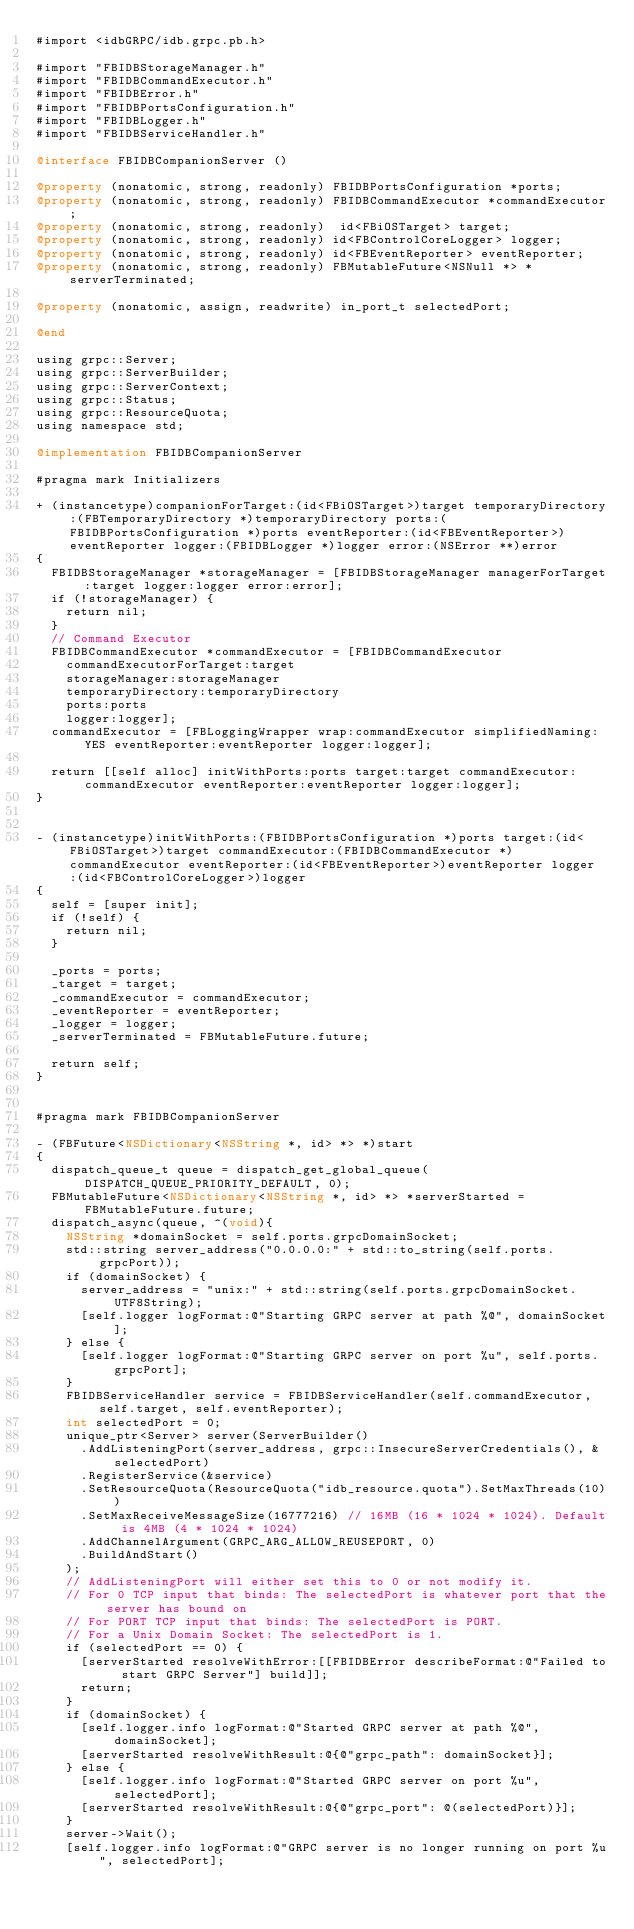<code> <loc_0><loc_0><loc_500><loc_500><_ObjectiveC_>#import <idbGRPC/idb.grpc.pb.h>

#import "FBIDBStorageManager.h"
#import "FBIDBCommandExecutor.h"
#import "FBIDBError.h"
#import "FBIDBPortsConfiguration.h"
#import "FBIDBLogger.h"
#import "FBIDBServiceHandler.h"

@interface FBIDBCompanionServer ()

@property (nonatomic, strong, readonly) FBIDBPortsConfiguration *ports;
@property (nonatomic, strong, readonly) FBIDBCommandExecutor *commandExecutor;
@property (nonatomic, strong, readonly)  id<FBiOSTarget> target;
@property (nonatomic, strong, readonly) id<FBControlCoreLogger> logger;
@property (nonatomic, strong, readonly) id<FBEventReporter> eventReporter;
@property (nonatomic, strong, readonly) FBMutableFuture<NSNull *> *serverTerminated;

@property (nonatomic, assign, readwrite) in_port_t selectedPort;

@end

using grpc::Server;
using grpc::ServerBuilder;
using grpc::ServerContext;
using grpc::Status;
using grpc::ResourceQuota;
using namespace std;

@implementation FBIDBCompanionServer

#pragma mark Initializers

+ (instancetype)companionForTarget:(id<FBiOSTarget>)target temporaryDirectory:(FBTemporaryDirectory *)temporaryDirectory ports:(FBIDBPortsConfiguration *)ports eventReporter:(id<FBEventReporter>)eventReporter logger:(FBIDBLogger *)logger error:(NSError **)error
{
  FBIDBStorageManager *storageManager = [FBIDBStorageManager managerForTarget:target logger:logger error:error];
  if (!storageManager) {
    return nil;
  }
  // Command Executor
  FBIDBCommandExecutor *commandExecutor = [FBIDBCommandExecutor
    commandExecutorForTarget:target
    storageManager:storageManager
    temporaryDirectory:temporaryDirectory
    ports:ports
    logger:logger];
  commandExecutor = [FBLoggingWrapper wrap:commandExecutor simplifiedNaming:YES eventReporter:eventReporter logger:logger];

  return [[self alloc] initWithPorts:ports target:target commandExecutor:commandExecutor eventReporter:eventReporter logger:logger];
}


- (instancetype)initWithPorts:(FBIDBPortsConfiguration *)ports target:(id<FBiOSTarget>)target commandExecutor:(FBIDBCommandExecutor *)commandExecutor eventReporter:(id<FBEventReporter>)eventReporter logger:(id<FBControlCoreLogger>)logger
{
  self = [super init];
  if (!self) {
    return nil;
  }

  _ports = ports;
  _target = target;
  _commandExecutor = commandExecutor;
  _eventReporter = eventReporter;
  _logger = logger;
  _serverTerminated = FBMutableFuture.future;

  return self;
}


#pragma mark FBIDBCompanionServer

- (FBFuture<NSDictionary<NSString *, id> *> *)start
{
  dispatch_queue_t queue = dispatch_get_global_queue( DISPATCH_QUEUE_PRIORITY_DEFAULT, 0);
  FBMutableFuture<NSDictionary<NSString *, id> *> *serverStarted = FBMutableFuture.future;
  dispatch_async(queue, ^(void){
    NSString *domainSocket = self.ports.grpcDomainSocket;
    std::string server_address("0.0.0.0:" + std::to_string(self.ports.grpcPort));
    if (domainSocket) {
      server_address = "unix:" + std::string(self.ports.grpcDomainSocket.UTF8String);
      [self.logger logFormat:@"Starting GRPC server at path %@", domainSocket];
    } else {
      [self.logger logFormat:@"Starting GRPC server on port %u", self.ports.grpcPort];
    }
    FBIDBServiceHandler service = FBIDBServiceHandler(self.commandExecutor, self.target, self.eventReporter);
    int selectedPort = 0;
    unique_ptr<Server> server(ServerBuilder()
      .AddListeningPort(server_address, grpc::InsecureServerCredentials(), &selectedPort)
      .RegisterService(&service)
      .SetResourceQuota(ResourceQuota("idb_resource.quota").SetMaxThreads(10))
      .SetMaxReceiveMessageSize(16777216) // 16MB (16 * 1024 * 1024). Default is 4MB (4 * 1024 * 1024)
      .AddChannelArgument(GRPC_ARG_ALLOW_REUSEPORT, 0)
      .BuildAndStart()
    );
    // AddListeningPort will either set this to 0 or not modify it.
    // For 0 TCP input that binds: The selectedPort is whatever port that the server has bound on
    // For PORT TCP input that binds: The selectedPort is PORT.
    // For a Unix Domain Socket: The selectedPort is 1.
    if (selectedPort == 0) {
      [serverStarted resolveWithError:[[FBIDBError describeFormat:@"Failed to start GRPC Server"] build]];
      return;
    }
    if (domainSocket) {
      [self.logger.info logFormat:@"Started GRPC server at path %@", domainSocket];
      [serverStarted resolveWithResult:@{@"grpc_path": domainSocket}];
    } else {
      [self.logger.info logFormat:@"Started GRPC server on port %u", selectedPort];
      [serverStarted resolveWithResult:@{@"grpc_port": @(selectedPort)}];
    }
    server->Wait();
    [self.logger.info logFormat:@"GRPC server is no longer running on port %u", selectedPort];</code> 